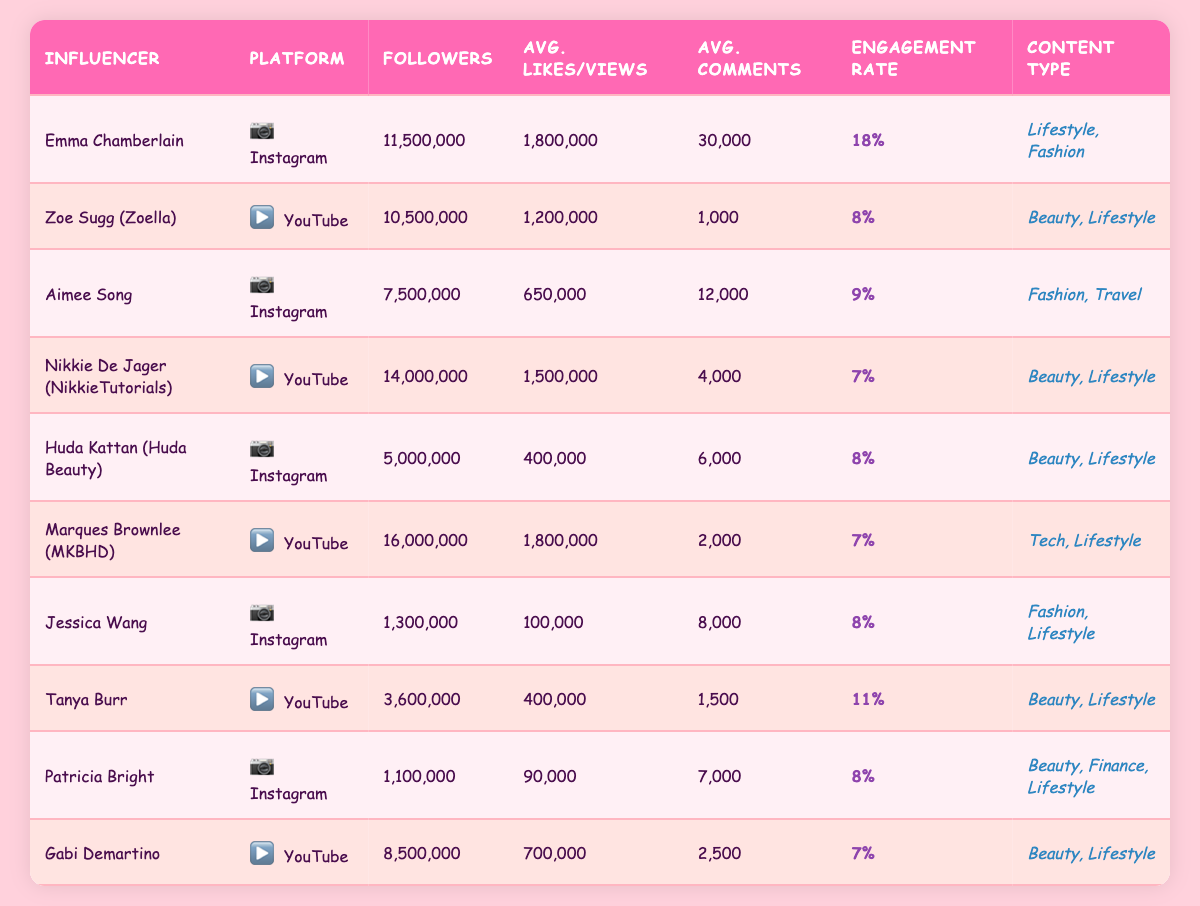What is the engagement rate of Emma Chamberlain on Instagram? The table shows that Emma Chamberlain's engagement rate listed under the Instagram platform is 18%.
Answer: 18% Which influencer has the highest number of followers on YouTube? From the table, Marques Brownlee (MKBHD) has the most followers on YouTube, with 16,000,000 followers.
Answer: Marques Brownlee (MKBHD) What type of content does Huda Kattan focus on? The content type for Huda Kattan listed in the table is "Beauty, Lifestyle."
Answer: Beauty, Lifestyle Calculate the average followers of influencers on Instagram from the table. For Instagram, the followers are: 11,500,000 (Emma) + 7,500,000 (Aimee) + 5,000,000 (Huda) + 1,300,000 (Jessica) + 1,100,000 (Patricia) = 26,400,000. There are 5 influencers, so the average is 26,400,000 / 5 = 5,280,000.
Answer: 5,280,000 Is Nikkie De Jager's engagement rate higher than that of Aimee Song? Nikkie De Jager has an engagement rate of 7% while Aimee Song has 9%. Since 9% > 7%, the answer is false.
Answer: No Which influencer has the highest average likes on Instagram? Emma Chamberlain has the highest average likes of 1,800,000 on Instagram.
Answer: Emma Chamberlain What is the difference in average views between Zoe Sugg and Marques Brownlee? Zoe Sugg has an average of 1,200,000 views, while Marques Brownlee has 1,800,000. The difference is 1,800,000 - 1,200,000 = 600,000.
Answer: 600,000 List the influencer with the lowest engagement rate on YouTube. Reviewing the data, Nikkie De Jager, Gabi Demartino, and Marques Brownlee all have an engagement rate of 7%. Therefore, they share the lowest engagement rate on YouTube.
Answer: Nikkie De Jager (NikkieTutorials), Gabi Demartino, Marques Brownlee (MKBHD) Calculate the average engagement rate of influencers from both platforms. The engagement rates are: 18%, 8%, 9%, 7%, 8%, 7%, 8%, 11%, 8%, 7%. Adding these gives 81%, and dividing by 10 gives an average of 8.1%.
Answer: 8.1% Are there more influencers focusing on Beauty or Lifestyle content? The table lists influencers categorized under "Beauty, Lifestyle" and "Beauty, Finance, Lifestyle," plus others under "Lifestyle." Counting these shows there are 5 beauty-focused and at least 5 lifestyle-focused influencers thus, "No" as Lifestyle is represented among those who also include Beauty.
Answer: No 